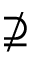Convert formula to latex. <formula><loc_0><loc_0><loc_500><loc_500>\nsupseteq</formula> 